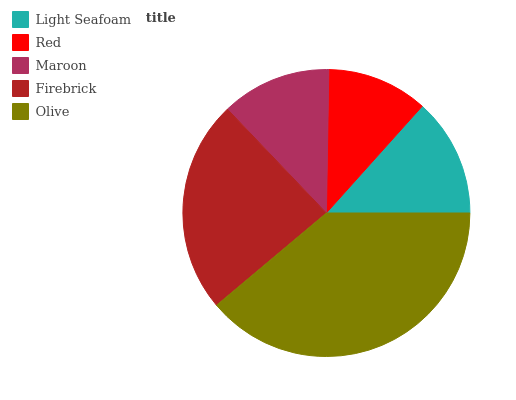Is Red the minimum?
Answer yes or no. Yes. Is Olive the maximum?
Answer yes or no. Yes. Is Maroon the minimum?
Answer yes or no. No. Is Maroon the maximum?
Answer yes or no. No. Is Maroon greater than Red?
Answer yes or no. Yes. Is Red less than Maroon?
Answer yes or no. Yes. Is Red greater than Maroon?
Answer yes or no. No. Is Maroon less than Red?
Answer yes or no. No. Is Light Seafoam the high median?
Answer yes or no. Yes. Is Light Seafoam the low median?
Answer yes or no. Yes. Is Red the high median?
Answer yes or no. No. Is Firebrick the low median?
Answer yes or no. No. 